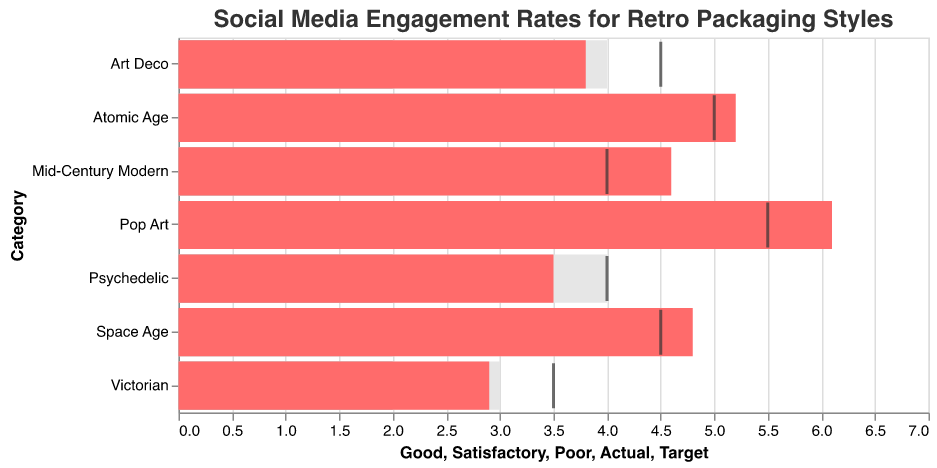What is the title of the figure? The title is located at the top of the figure and it reads "Social Media Engagement Rates for Retro Packaging Styles".
Answer: Social Media Engagement Rates for Retro Packaging Styles How many categories of retro packaging styles are compared in the figure? By counting the number of different categories listed along the y-axis, we see that there are 7 categories: Art Deco, Atomic Age, Mid-Century Modern, Pop Art, Psychedelic, Victorian, and Space Age.
Answer: 7 Which retro packaging style has the highest actual engagement rate? By observing the bars for the 'Actual' engagement rates (highlighted in pink), we see that 'Pop Art' has the highest bar.
Answer: Pop Art What engagement rate did 'Mid-Century Modern' achieve compared to its target? 'Mid-Century Modern' has an actual engagement rate of 4.6, and its target is 4.0. The actual rate exceeds the target by 0.6.
Answer: Exceeds by 0.6 Which retro packaging styles met or exceeded their target engagement rates? By comparing the actual engagement bars against the target ticks, we see that 'Atomic Age' (5.2 > 5.0), 'Mid-Century Modern' (4.6 > 4.0), 'Pop Art' (6.1 > 5.5), and 'Space Age' (4.8 > 4.5) met or exceeded their targets.
Answer: Atomic Age, Mid-Century Modern, Pop Art, Space Age What is the engagement rate range considered 'Good' for 'Victorian'? According to the shaded areas behind the bars, the 'Good' range for 'Victorian' extends from 0 to 3.
Answer: 0 to 3 How does the 'Satisfactory' engagement rate range for 'Atomic Age' compare to 'Pol Art'? The 'Satisfactory' range for 'Atomic Age' is from 0 to 3, while for 'Pop Art' it is from 0 to 3 as well, so they are the same.
Answer: Same For which category is the actual engagement rate furthest from the target? We look for the largest numerical difference between the actual rate and the target. For 'Pop Art', the actual rate (6.1) differs from the target (5.5) by 0.6, which is the largest deviation compared to other categories.
Answer: Pop Art What's the sum of the actual engagement rates for 'Psychedelic' and 'Victorian'? The actual engagement rate for 'Psychedelic' is 3.5 and for 'Victorian' it's 2.9. Summing these gives 3.5 + 2.9 = 6.4.
Answer: 6.4 